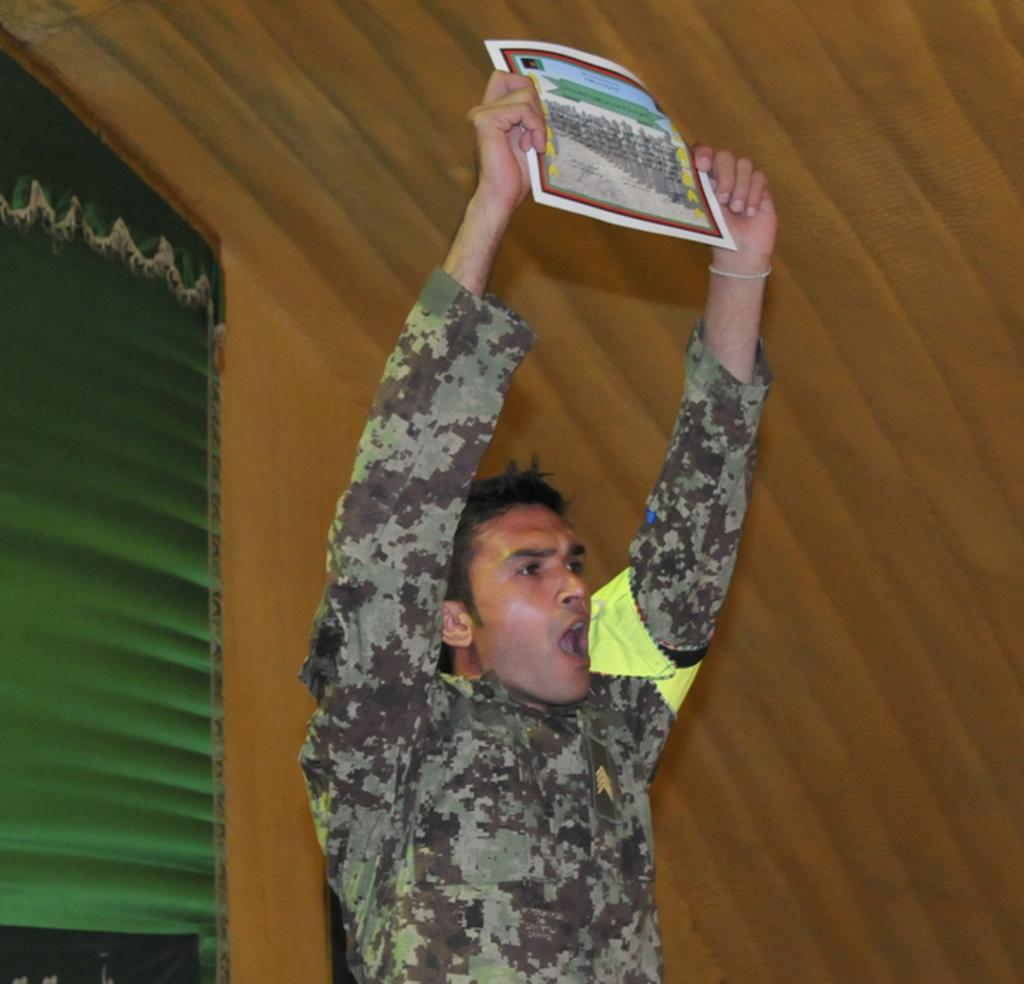What is the person in the image holding? The person is holding a poster in the image. What can be seen on the left side of the image? There is a curtain on the left side of the image. What type of wall is visible in the background of the image? There is a wooden wall in the background of the image. What type of marble is visible on the wooden wall in the image? There is no marble visible on the wooden wall in the image; it is made of wood. 